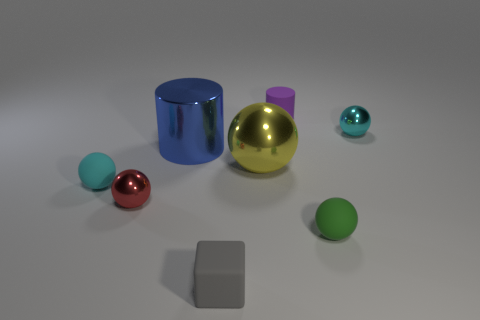What could be the purpose of this arrangement of objects? This arrangement could be an artistic composition intended to play with color contrast and reflections, or it could be a setup for a physics demonstration about the properties of different materials and shapes. 